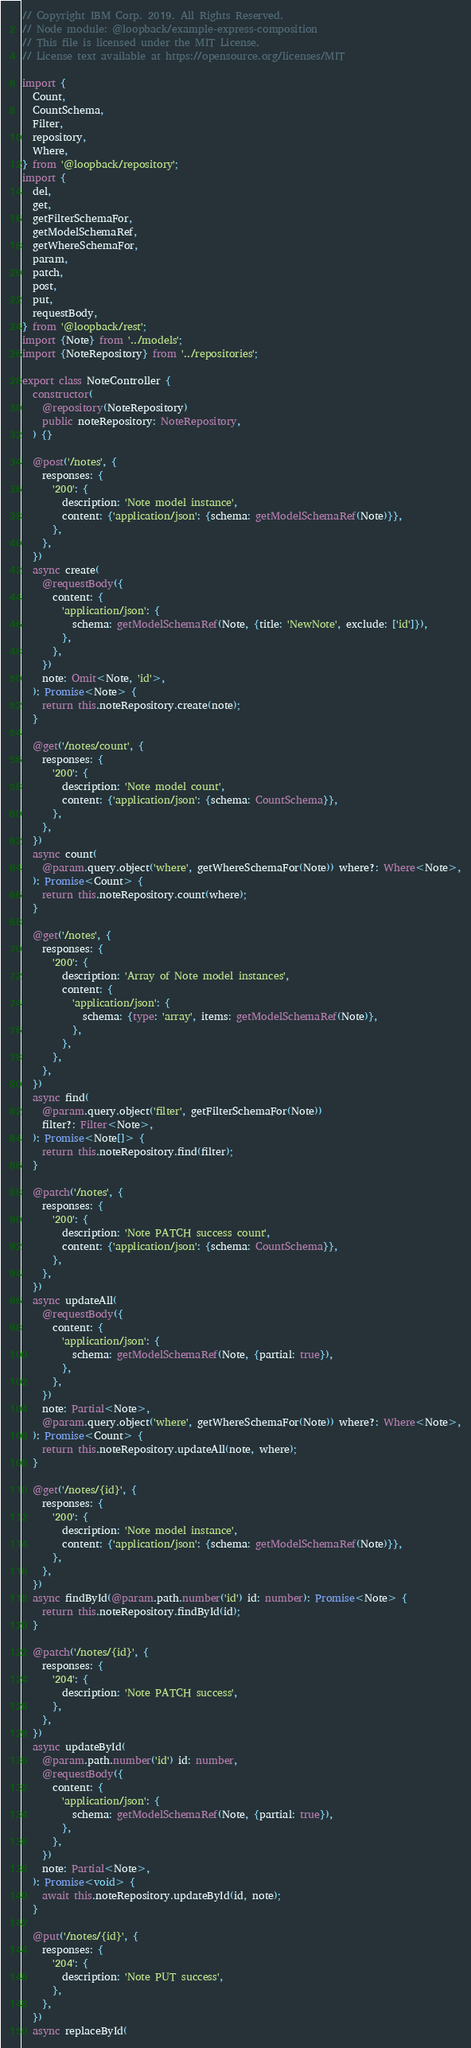<code> <loc_0><loc_0><loc_500><loc_500><_TypeScript_>// Copyright IBM Corp. 2019. All Rights Reserved.
// Node module: @loopback/example-express-composition
// This file is licensed under the MIT License.
// License text available at https://opensource.org/licenses/MIT

import {
  Count,
  CountSchema,
  Filter,
  repository,
  Where,
} from '@loopback/repository';
import {
  del,
  get,
  getFilterSchemaFor,
  getModelSchemaRef,
  getWhereSchemaFor,
  param,
  patch,
  post,
  put,
  requestBody,
} from '@loopback/rest';
import {Note} from '../models';
import {NoteRepository} from '../repositories';

export class NoteController {
  constructor(
    @repository(NoteRepository)
    public noteRepository: NoteRepository,
  ) {}

  @post('/notes', {
    responses: {
      '200': {
        description: 'Note model instance',
        content: {'application/json': {schema: getModelSchemaRef(Note)}},
      },
    },
  })
  async create(
    @requestBody({
      content: {
        'application/json': {
          schema: getModelSchemaRef(Note, {title: 'NewNote', exclude: ['id']}),
        },
      },
    })
    note: Omit<Note, 'id'>,
  ): Promise<Note> {
    return this.noteRepository.create(note);
  }

  @get('/notes/count', {
    responses: {
      '200': {
        description: 'Note model count',
        content: {'application/json': {schema: CountSchema}},
      },
    },
  })
  async count(
    @param.query.object('where', getWhereSchemaFor(Note)) where?: Where<Note>,
  ): Promise<Count> {
    return this.noteRepository.count(where);
  }

  @get('/notes', {
    responses: {
      '200': {
        description: 'Array of Note model instances',
        content: {
          'application/json': {
            schema: {type: 'array', items: getModelSchemaRef(Note)},
          },
        },
      },
    },
  })
  async find(
    @param.query.object('filter', getFilterSchemaFor(Note))
    filter?: Filter<Note>,
  ): Promise<Note[]> {
    return this.noteRepository.find(filter);
  }

  @patch('/notes', {
    responses: {
      '200': {
        description: 'Note PATCH success count',
        content: {'application/json': {schema: CountSchema}},
      },
    },
  })
  async updateAll(
    @requestBody({
      content: {
        'application/json': {
          schema: getModelSchemaRef(Note, {partial: true}),
        },
      },
    })
    note: Partial<Note>,
    @param.query.object('where', getWhereSchemaFor(Note)) where?: Where<Note>,
  ): Promise<Count> {
    return this.noteRepository.updateAll(note, where);
  }

  @get('/notes/{id}', {
    responses: {
      '200': {
        description: 'Note model instance',
        content: {'application/json': {schema: getModelSchemaRef(Note)}},
      },
    },
  })
  async findById(@param.path.number('id') id: number): Promise<Note> {
    return this.noteRepository.findById(id);
  }

  @patch('/notes/{id}', {
    responses: {
      '204': {
        description: 'Note PATCH success',
      },
    },
  })
  async updateById(
    @param.path.number('id') id: number,
    @requestBody({
      content: {
        'application/json': {
          schema: getModelSchemaRef(Note, {partial: true}),
        },
      },
    })
    note: Partial<Note>,
  ): Promise<void> {
    await this.noteRepository.updateById(id, note);
  }

  @put('/notes/{id}', {
    responses: {
      '204': {
        description: 'Note PUT success',
      },
    },
  })
  async replaceById(</code> 